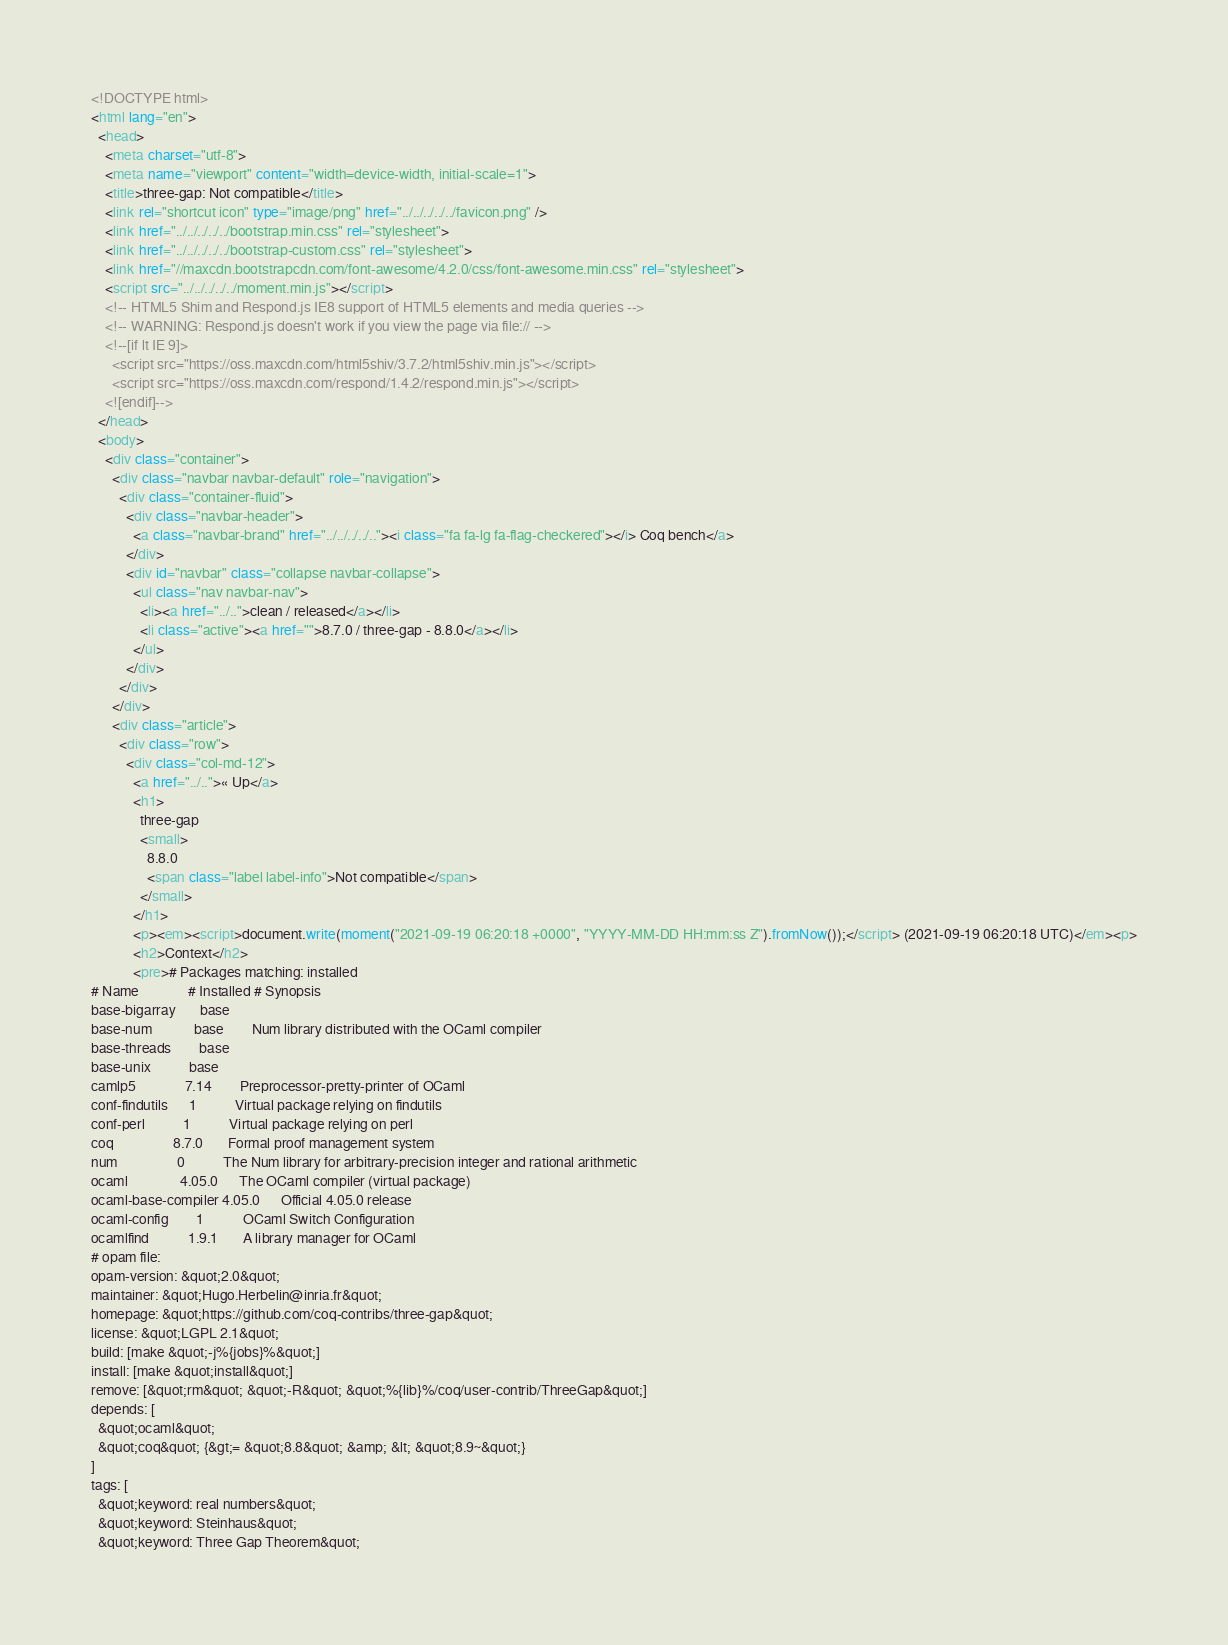Convert code to text. <code><loc_0><loc_0><loc_500><loc_500><_HTML_><!DOCTYPE html>
<html lang="en">
  <head>
    <meta charset="utf-8">
    <meta name="viewport" content="width=device-width, initial-scale=1">
    <title>three-gap: Not compatible</title>
    <link rel="shortcut icon" type="image/png" href="../../../../../favicon.png" />
    <link href="../../../../../bootstrap.min.css" rel="stylesheet">
    <link href="../../../../../bootstrap-custom.css" rel="stylesheet">
    <link href="//maxcdn.bootstrapcdn.com/font-awesome/4.2.0/css/font-awesome.min.css" rel="stylesheet">
    <script src="../../../../../moment.min.js"></script>
    <!-- HTML5 Shim and Respond.js IE8 support of HTML5 elements and media queries -->
    <!-- WARNING: Respond.js doesn't work if you view the page via file:// -->
    <!--[if lt IE 9]>
      <script src="https://oss.maxcdn.com/html5shiv/3.7.2/html5shiv.min.js"></script>
      <script src="https://oss.maxcdn.com/respond/1.4.2/respond.min.js"></script>
    <![endif]-->
  </head>
  <body>
    <div class="container">
      <div class="navbar navbar-default" role="navigation">
        <div class="container-fluid">
          <div class="navbar-header">
            <a class="navbar-brand" href="../../../../.."><i class="fa fa-lg fa-flag-checkered"></i> Coq bench</a>
          </div>
          <div id="navbar" class="collapse navbar-collapse">
            <ul class="nav navbar-nav">
              <li><a href="../..">clean / released</a></li>
              <li class="active"><a href="">8.7.0 / three-gap - 8.8.0</a></li>
            </ul>
          </div>
        </div>
      </div>
      <div class="article">
        <div class="row">
          <div class="col-md-12">
            <a href="../..">« Up</a>
            <h1>
              three-gap
              <small>
                8.8.0
                <span class="label label-info">Not compatible</span>
              </small>
            </h1>
            <p><em><script>document.write(moment("2021-09-19 06:20:18 +0000", "YYYY-MM-DD HH:mm:ss Z").fromNow());</script> (2021-09-19 06:20:18 UTC)</em><p>
            <h2>Context</h2>
            <pre># Packages matching: installed
# Name              # Installed # Synopsis
base-bigarray       base
base-num            base        Num library distributed with the OCaml compiler
base-threads        base
base-unix           base
camlp5              7.14        Preprocessor-pretty-printer of OCaml
conf-findutils      1           Virtual package relying on findutils
conf-perl           1           Virtual package relying on perl
coq                 8.7.0       Formal proof management system
num                 0           The Num library for arbitrary-precision integer and rational arithmetic
ocaml               4.05.0      The OCaml compiler (virtual package)
ocaml-base-compiler 4.05.0      Official 4.05.0 release
ocaml-config        1           OCaml Switch Configuration
ocamlfind           1.9.1       A library manager for OCaml
# opam file:
opam-version: &quot;2.0&quot;
maintainer: &quot;Hugo.Herbelin@inria.fr&quot;
homepage: &quot;https://github.com/coq-contribs/three-gap&quot;
license: &quot;LGPL 2.1&quot;
build: [make &quot;-j%{jobs}%&quot;]
install: [make &quot;install&quot;]
remove: [&quot;rm&quot; &quot;-R&quot; &quot;%{lib}%/coq/user-contrib/ThreeGap&quot;]
depends: [
  &quot;ocaml&quot;
  &quot;coq&quot; {&gt;= &quot;8.8&quot; &amp; &lt; &quot;8.9~&quot;}
]
tags: [
  &quot;keyword: real numbers&quot;
  &quot;keyword: Steinhaus&quot;
  &quot;keyword: Three Gap Theorem&quot;</code> 